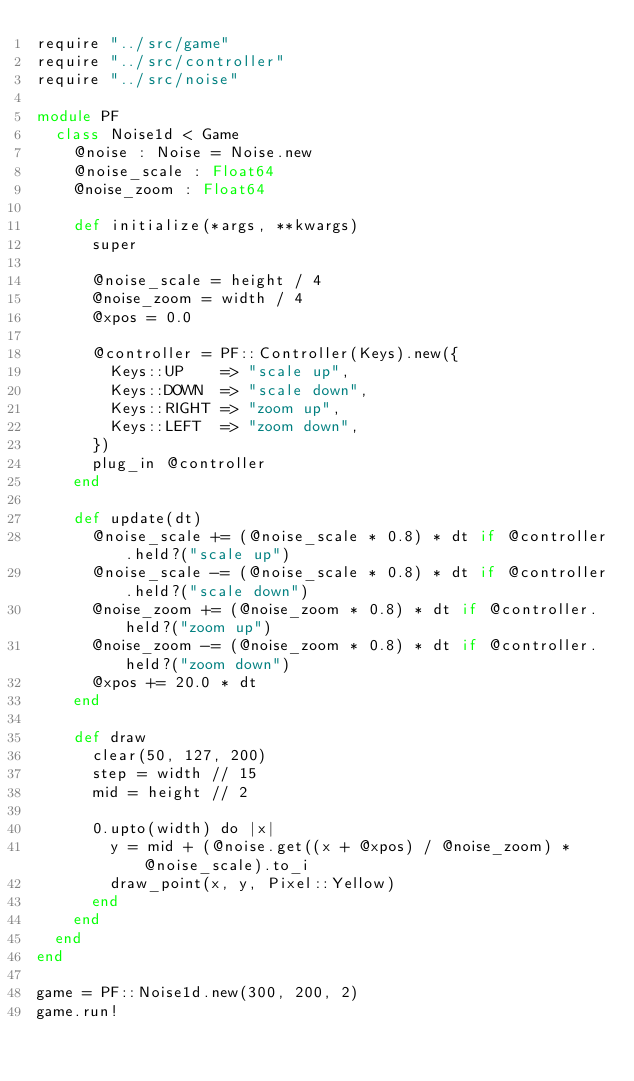Convert code to text. <code><loc_0><loc_0><loc_500><loc_500><_Crystal_>require "../src/game"
require "../src/controller"
require "../src/noise"

module PF
  class Noise1d < Game
    @noise : Noise = Noise.new
    @noise_scale : Float64
    @noise_zoom : Float64

    def initialize(*args, **kwargs)
      super

      @noise_scale = height / 4
      @noise_zoom = width / 4
      @xpos = 0.0

      @controller = PF::Controller(Keys).new({
        Keys::UP    => "scale up",
        Keys::DOWN  => "scale down",
        Keys::RIGHT => "zoom up",
        Keys::LEFT  => "zoom down",
      })
      plug_in @controller
    end

    def update(dt)
      @noise_scale += (@noise_scale * 0.8) * dt if @controller.held?("scale up")
      @noise_scale -= (@noise_scale * 0.8) * dt if @controller.held?("scale down")
      @noise_zoom += (@noise_zoom * 0.8) * dt if @controller.held?("zoom up")
      @noise_zoom -= (@noise_zoom * 0.8) * dt if @controller.held?("zoom down")
      @xpos += 20.0 * dt
    end

    def draw
      clear(50, 127, 200)
      step = width // 15
      mid = height // 2

      0.upto(width) do |x|
        y = mid + (@noise.get((x + @xpos) / @noise_zoom) * @noise_scale).to_i
        draw_point(x, y, Pixel::Yellow)
      end
    end
  end
end

game = PF::Noise1d.new(300, 200, 2)
game.run!
</code> 